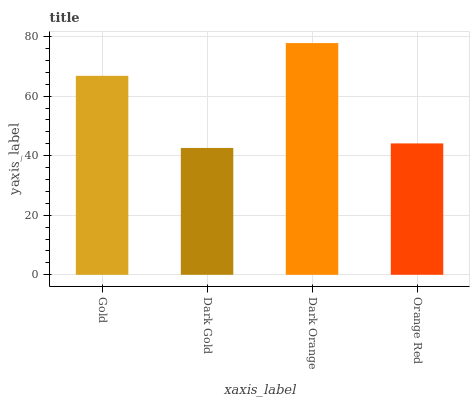Is Dark Orange the maximum?
Answer yes or no. Yes. Is Dark Orange the minimum?
Answer yes or no. No. Is Dark Gold the maximum?
Answer yes or no. No. Is Dark Orange greater than Dark Gold?
Answer yes or no. Yes. Is Dark Gold less than Dark Orange?
Answer yes or no. Yes. Is Dark Gold greater than Dark Orange?
Answer yes or no. No. Is Dark Orange less than Dark Gold?
Answer yes or no. No. Is Gold the high median?
Answer yes or no. Yes. Is Orange Red the low median?
Answer yes or no. Yes. Is Dark Orange the high median?
Answer yes or no. No. Is Dark Orange the low median?
Answer yes or no. No. 